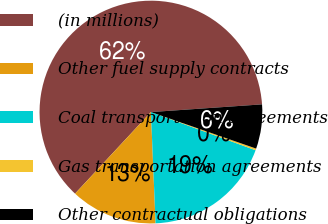<chart> <loc_0><loc_0><loc_500><loc_500><pie_chart><fcel>(in millions)<fcel>Other fuel supply contracts<fcel>Coal transportation agreements<fcel>Gas transportation agreements<fcel>Other contractual obligations<nl><fcel>61.98%<fcel>12.59%<fcel>18.77%<fcel>0.25%<fcel>6.42%<nl></chart> 